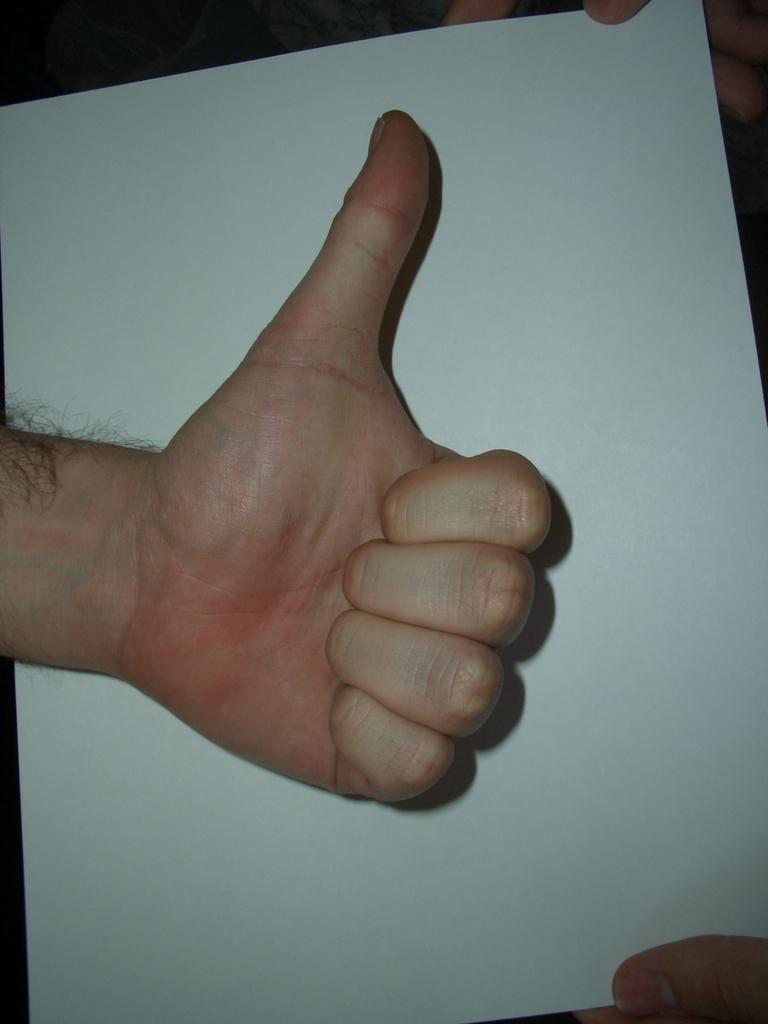What is the main subject of the image? There is a guy in the image. What is the guy doing with his thumb finger? The guy is pointing his thumb finger upwards. What is the guy doing with his other fingers? The guy's other fingers are pointing downwards. What color is the paint on the guy's shirt in the image? There is no paint or shirt mentioned in the image; it only describes the guy's finger positions. 